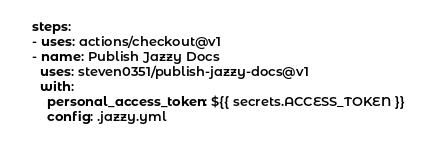Convert code to text. <code><loc_0><loc_0><loc_500><loc_500><_YAML_>    steps:
    - uses: actions/checkout@v1
    - name: Publish Jazzy Docs
      uses: steven0351/publish-jazzy-docs@v1
      with:
        personal_access_token: ${{ secrets.ACCESS_TOKEN }}
        config: .jazzy.yml
</code> 